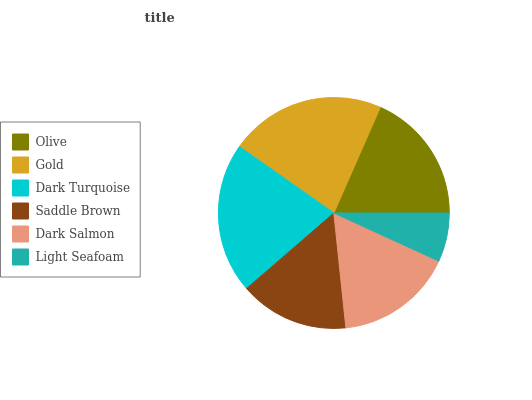Is Light Seafoam the minimum?
Answer yes or no. Yes. Is Gold the maximum?
Answer yes or no. Yes. Is Dark Turquoise the minimum?
Answer yes or no. No. Is Dark Turquoise the maximum?
Answer yes or no. No. Is Gold greater than Dark Turquoise?
Answer yes or no. Yes. Is Dark Turquoise less than Gold?
Answer yes or no. Yes. Is Dark Turquoise greater than Gold?
Answer yes or no. No. Is Gold less than Dark Turquoise?
Answer yes or no. No. Is Olive the high median?
Answer yes or no. Yes. Is Dark Salmon the low median?
Answer yes or no. Yes. Is Saddle Brown the high median?
Answer yes or no. No. Is Olive the low median?
Answer yes or no. No. 